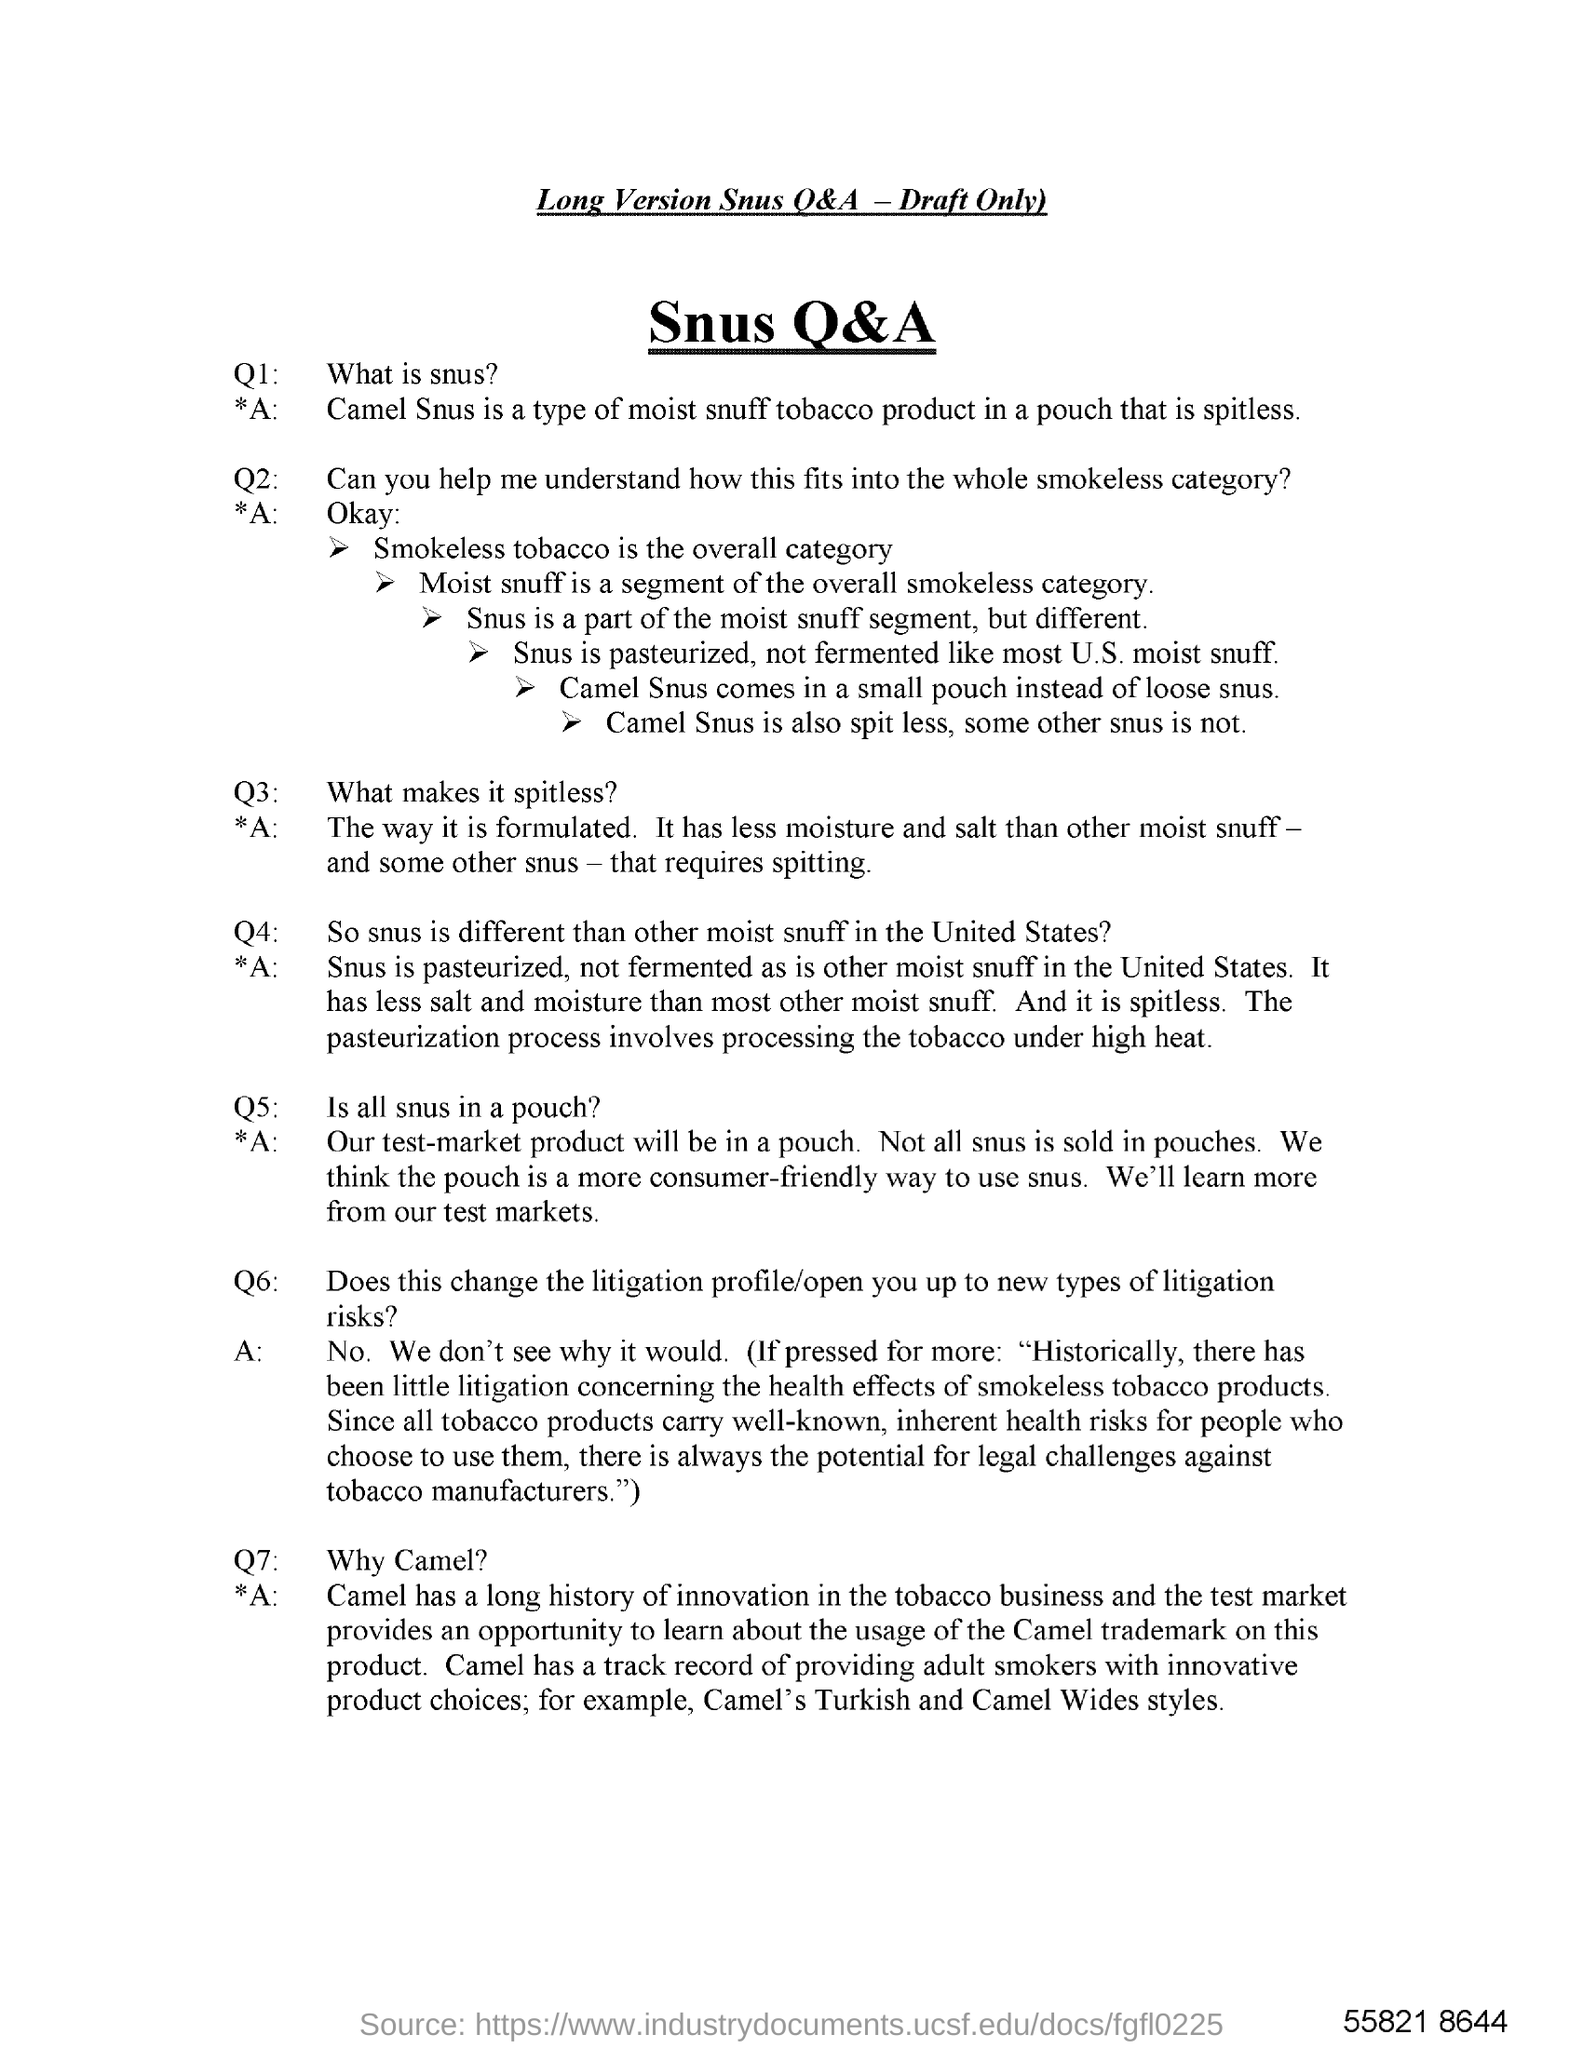What is meant by Camel Snus?
Provide a short and direct response. Type of moist snuff tobacco product in a pouch that is spitless. 